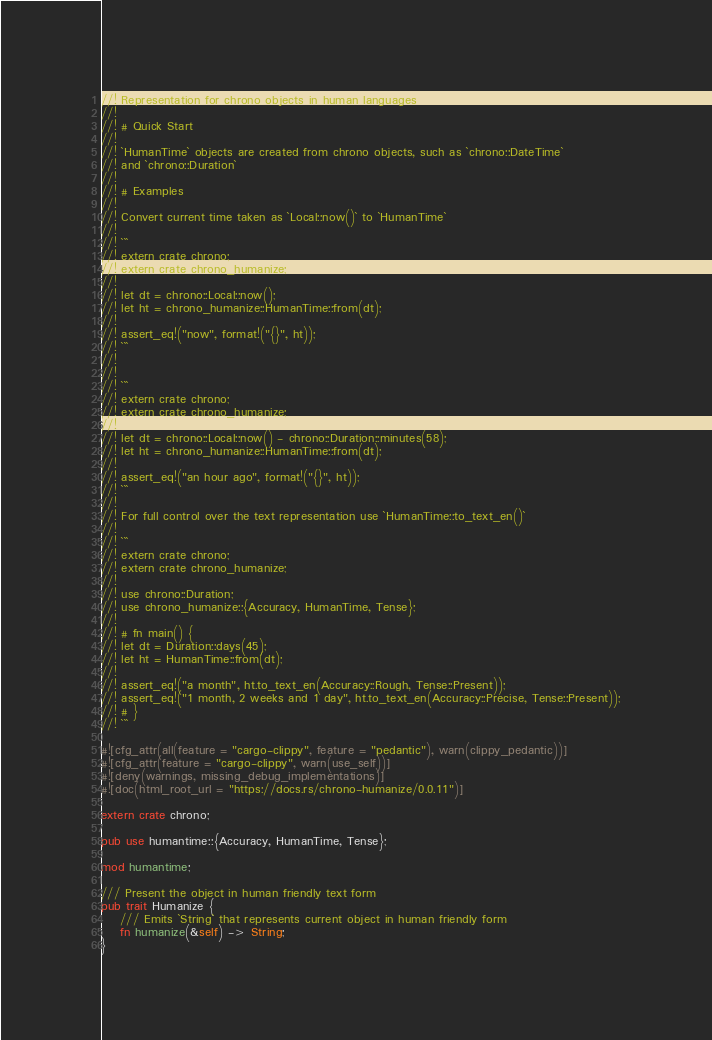Convert code to text. <code><loc_0><loc_0><loc_500><loc_500><_Rust_>//! Representation for chrono objects in human languages
//!
//! # Quick Start
//!
//! `HumanTime` objects are created from chrono objects, such as `chrono::DateTime`
//! and `chrono::Duration`
//!
//! # Examples
//!
//! Convert current time taken as `Local::now()` to `HumanTime`
//!
//! ```
//! extern crate chrono;
//! extern crate chrono_humanize;
//!
//! let dt = chrono::Local::now();
//! let ht = chrono_humanize::HumanTime::from(dt);
//!
//! assert_eq!("now", format!("{}", ht));
//! ```
//!
//!
//! ```
//! extern crate chrono;
//! extern crate chrono_humanize;
//!
//! let dt = chrono::Local::now() - chrono::Duration::minutes(58);
//! let ht = chrono_humanize::HumanTime::from(dt);
//!
//! assert_eq!("an hour ago", format!("{}", ht));
//! ```
//!
//! For full control over the text representation use `HumanTime::to_text_en()`
//!
//! ```
//! extern crate chrono;
//! extern crate chrono_humanize;
//!
//! use chrono::Duration;
//! use chrono_humanize::{Accuracy, HumanTime, Tense};
//!
//! # fn main() {
//! let dt = Duration::days(45);
//! let ht = HumanTime::from(dt);
//!
//! assert_eq!("a month", ht.to_text_en(Accuracy::Rough, Tense::Present));
//! assert_eq!("1 month, 2 weeks and 1 day", ht.to_text_en(Accuracy::Precise, Tense::Present));
//! # }
//! ```

#![cfg_attr(all(feature = "cargo-clippy", feature = "pedantic"), warn(clippy_pedantic))]
#![cfg_attr(feature = "cargo-clippy", warn(use_self))]
#![deny(warnings, missing_debug_implementations)]
#![doc(html_root_url = "https://docs.rs/chrono-humanize/0.0.11")]

extern crate chrono;

pub use humantime::{Accuracy, HumanTime, Tense};

mod humantime;

/// Present the object in human friendly text form
pub trait Humanize {
    /// Emits `String` that represents current object in human friendly form
    fn humanize(&self) -> String;
}
</code> 